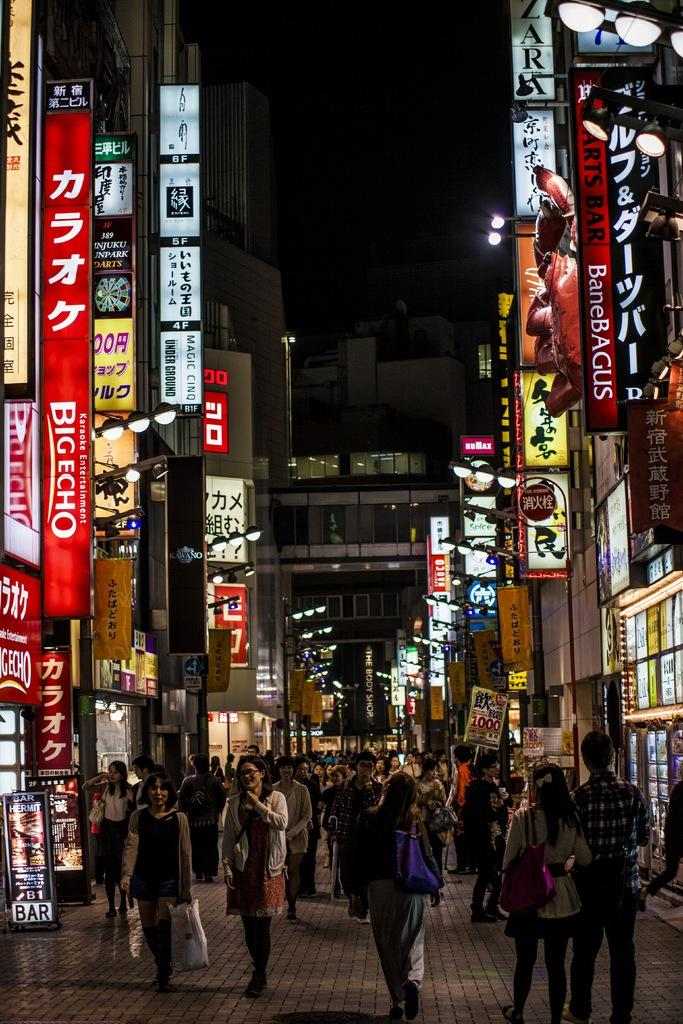<image>
Write a terse but informative summary of the picture. A street full of people and signs one of which says Big Echo. 